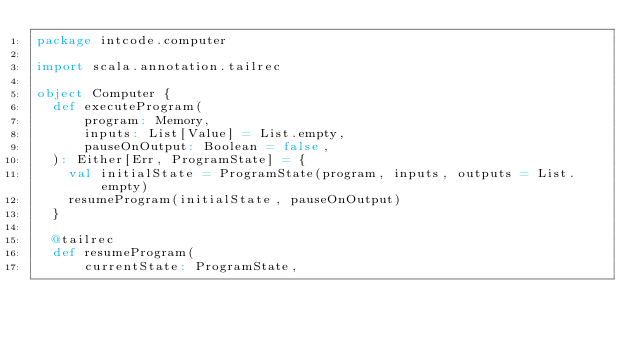<code> <loc_0><loc_0><loc_500><loc_500><_Scala_>package intcode.computer

import scala.annotation.tailrec

object Computer {
  def executeProgram(
      program: Memory,
      inputs: List[Value] = List.empty,
      pauseOnOutput: Boolean = false,
  ): Either[Err, ProgramState] = {
    val initialState = ProgramState(program, inputs, outputs = List.empty)
    resumeProgram(initialState, pauseOnOutput)
  }

  @tailrec
  def resumeProgram(
      currentState: ProgramState,</code> 